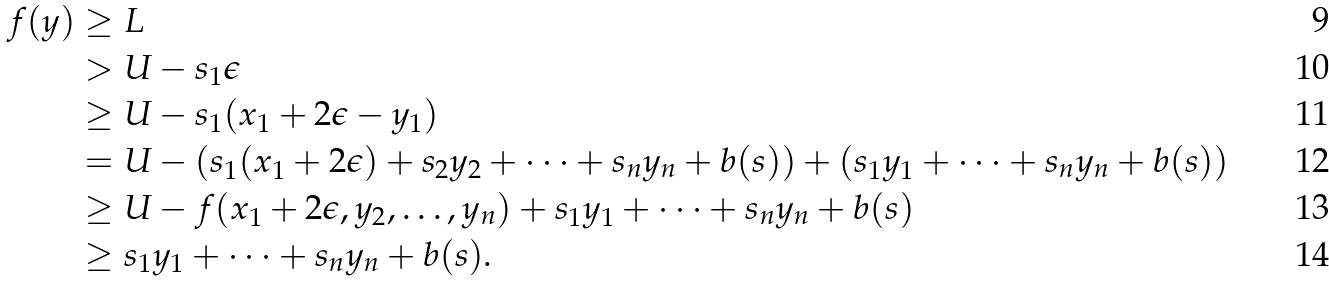<formula> <loc_0><loc_0><loc_500><loc_500>f ( y ) & \geq L \\ & > U - s _ { 1 } \epsilon \\ & \geq U - s _ { 1 } ( x _ { 1 } + 2 \epsilon - y _ { 1 } ) \\ & = U - ( s _ { 1 } ( x _ { 1 } + 2 \epsilon ) + s _ { 2 } y _ { 2 } + \cdots + s _ { n } y _ { n } + b ( s ) ) + ( s _ { 1 } y _ { 1 } + \cdots + s _ { n } y _ { n } + b ( s ) ) \\ & \geq U - f ( x _ { 1 } + 2 \epsilon , y _ { 2 } , \dots , y _ { n } ) + s _ { 1 } y _ { 1 } + \cdots + s _ { n } y _ { n } + b ( s ) \\ & \geq s _ { 1 } y _ { 1 } + \cdots + s _ { n } y _ { n } + b ( s ) .</formula> 